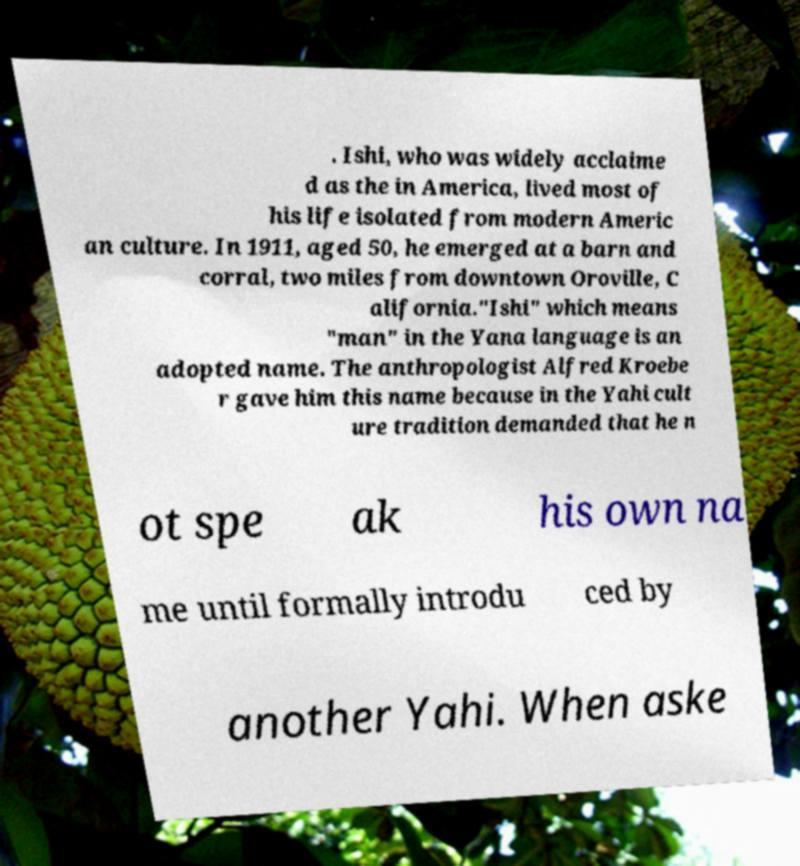Can you read and provide the text displayed in the image?This photo seems to have some interesting text. Can you extract and type it out for me? . Ishi, who was widely acclaime d as the in America, lived most of his life isolated from modern Americ an culture. In 1911, aged 50, he emerged at a barn and corral, two miles from downtown Oroville, C alifornia."Ishi" which means "man" in the Yana language is an adopted name. The anthropologist Alfred Kroebe r gave him this name because in the Yahi cult ure tradition demanded that he n ot spe ak his own na me until formally introdu ced by another Yahi. When aske 